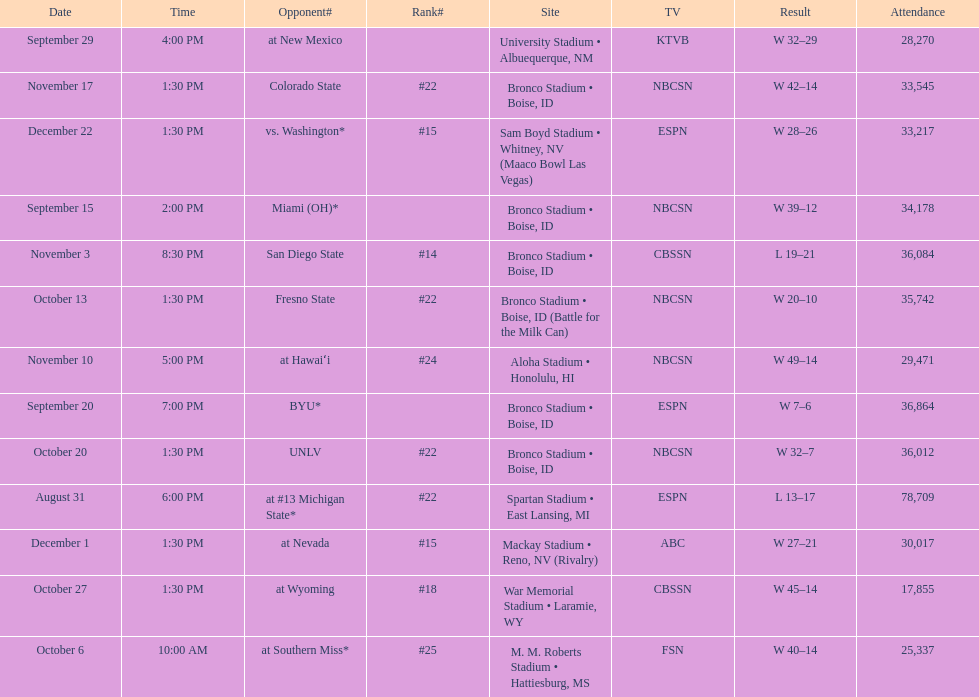What is the score difference for the game against michigan state? 4. Would you be able to parse every entry in this table? {'header': ['Date', 'Time', 'Opponent#', 'Rank#', 'Site', 'TV', 'Result', 'Attendance'], 'rows': [['September 29', '4:00 PM', 'at\xa0New Mexico', '', 'University Stadium • Albuequerque, NM', 'KTVB', 'W\xa032–29', '28,270'], ['November 17', '1:30 PM', 'Colorado State', '#22', 'Bronco Stadium • Boise, ID', 'NBCSN', 'W\xa042–14', '33,545'], ['December 22', '1:30 PM', 'vs.\xa0Washington*', '#15', 'Sam Boyd Stadium • Whitney, NV (Maaco Bowl Las Vegas)', 'ESPN', 'W\xa028–26', '33,217'], ['September 15', '2:00 PM', 'Miami (OH)*', '', 'Bronco Stadium • Boise, ID', 'NBCSN', 'W\xa039–12', '34,178'], ['November 3', '8:30 PM', 'San Diego State', '#14', 'Bronco Stadium • Boise, ID', 'CBSSN', 'L\xa019–21', '36,084'], ['October 13', '1:30 PM', 'Fresno State', '#22', 'Bronco Stadium • Boise, ID (Battle for the Milk Can)', 'NBCSN', 'W\xa020–10', '35,742'], ['November 10', '5:00 PM', 'at\xa0Hawaiʻi', '#24', 'Aloha Stadium • Honolulu, HI', 'NBCSN', 'W\xa049–14', '29,471'], ['September 20', '7:00 PM', 'BYU*', '', 'Bronco Stadium • Boise, ID', 'ESPN', 'W\xa07–6', '36,864'], ['October 20', '1:30 PM', 'UNLV', '#22', 'Bronco Stadium • Boise, ID', 'NBCSN', 'W\xa032–7', '36,012'], ['August 31', '6:00 PM', 'at\xa0#13\xa0Michigan State*', '#22', 'Spartan Stadium • East Lansing, MI', 'ESPN', 'L\xa013–17', '78,709'], ['December 1', '1:30 PM', 'at\xa0Nevada', '#15', 'Mackay Stadium • Reno, NV (Rivalry)', 'ABC', 'W\xa027–21', '30,017'], ['October 27', '1:30 PM', 'at\xa0Wyoming', '#18', 'War Memorial Stadium • Laramie, WY', 'CBSSN', 'W\xa045–14', '17,855'], ['October 6', '10:00 AM', 'at\xa0Southern Miss*', '#25', 'M. M. Roberts Stadium • Hattiesburg, MS', 'FSN', 'W\xa040–14', '25,337']]} 